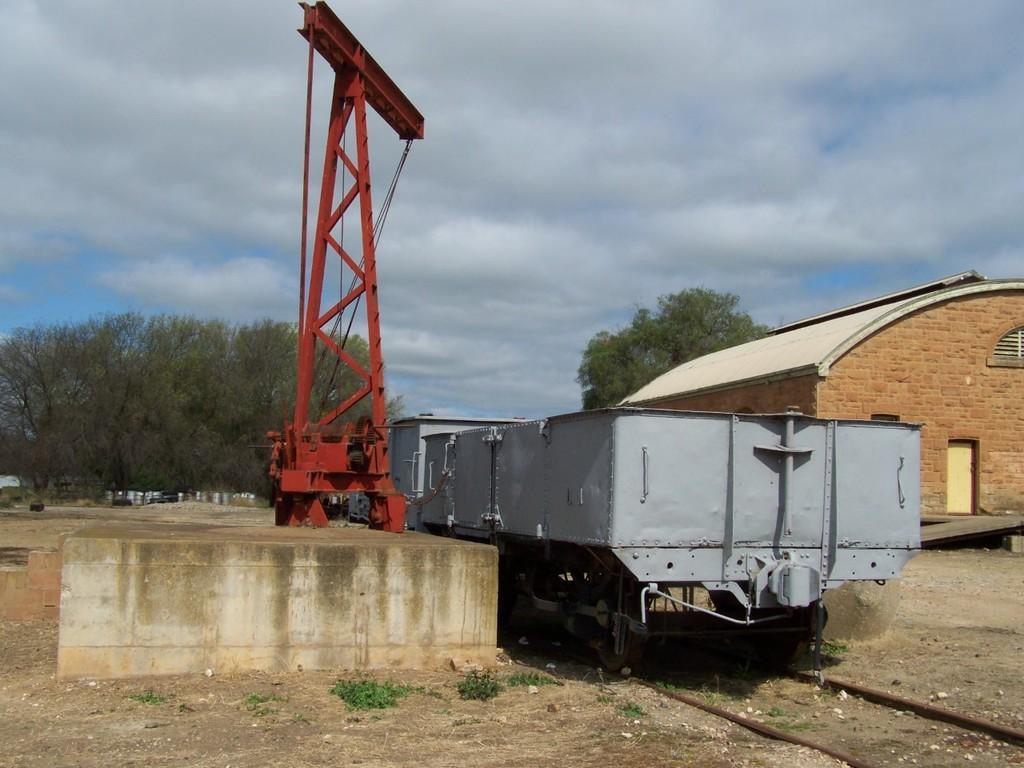In one or two sentences, can you explain what this image depicts? In this image we can see a goods train on the track. We can also see an electrical tower and a shed with a door and some windows. On the backside we can see some cars parked aside, a group of trees and the sky which looks cloudy. 